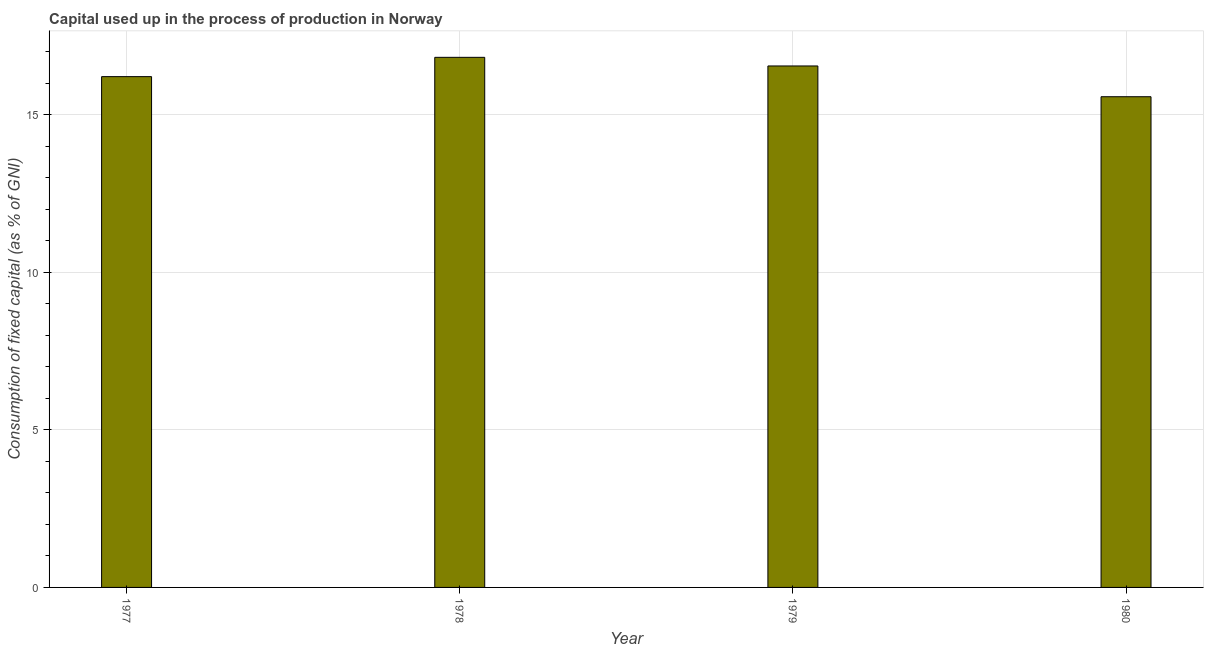What is the title of the graph?
Make the answer very short. Capital used up in the process of production in Norway. What is the label or title of the Y-axis?
Keep it short and to the point. Consumption of fixed capital (as % of GNI). What is the consumption of fixed capital in 1980?
Offer a very short reply. 15.57. Across all years, what is the maximum consumption of fixed capital?
Offer a very short reply. 16.82. Across all years, what is the minimum consumption of fixed capital?
Provide a succinct answer. 15.57. In which year was the consumption of fixed capital maximum?
Ensure brevity in your answer.  1978. What is the sum of the consumption of fixed capital?
Make the answer very short. 65.16. What is the difference between the consumption of fixed capital in 1977 and 1978?
Ensure brevity in your answer.  -0.61. What is the average consumption of fixed capital per year?
Give a very brief answer. 16.29. What is the median consumption of fixed capital?
Make the answer very short. 16.38. In how many years, is the consumption of fixed capital greater than 16 %?
Keep it short and to the point. 3. Do a majority of the years between 1977 and 1979 (inclusive) have consumption of fixed capital greater than 13 %?
Offer a terse response. Yes. What is the ratio of the consumption of fixed capital in 1977 to that in 1980?
Make the answer very short. 1.04. Is the consumption of fixed capital in 1978 less than that in 1980?
Offer a very short reply. No. Is the difference between the consumption of fixed capital in 1977 and 1980 greater than the difference between any two years?
Provide a succinct answer. No. What is the difference between the highest and the second highest consumption of fixed capital?
Offer a terse response. 0.27. Is the sum of the consumption of fixed capital in 1978 and 1980 greater than the maximum consumption of fixed capital across all years?
Keep it short and to the point. Yes. What is the difference between the highest and the lowest consumption of fixed capital?
Make the answer very short. 1.25. In how many years, is the consumption of fixed capital greater than the average consumption of fixed capital taken over all years?
Your response must be concise. 2. How many bars are there?
Your response must be concise. 4. Are all the bars in the graph horizontal?
Provide a succinct answer. No. What is the difference between two consecutive major ticks on the Y-axis?
Offer a terse response. 5. Are the values on the major ticks of Y-axis written in scientific E-notation?
Provide a short and direct response. No. What is the Consumption of fixed capital (as % of GNI) in 1977?
Ensure brevity in your answer.  16.21. What is the Consumption of fixed capital (as % of GNI) of 1978?
Provide a short and direct response. 16.82. What is the Consumption of fixed capital (as % of GNI) in 1979?
Provide a short and direct response. 16.55. What is the Consumption of fixed capital (as % of GNI) in 1980?
Offer a terse response. 15.57. What is the difference between the Consumption of fixed capital (as % of GNI) in 1977 and 1978?
Provide a succinct answer. -0.61. What is the difference between the Consumption of fixed capital (as % of GNI) in 1977 and 1979?
Your response must be concise. -0.34. What is the difference between the Consumption of fixed capital (as % of GNI) in 1977 and 1980?
Offer a very short reply. 0.64. What is the difference between the Consumption of fixed capital (as % of GNI) in 1978 and 1979?
Your answer should be compact. 0.27. What is the difference between the Consumption of fixed capital (as % of GNI) in 1978 and 1980?
Make the answer very short. 1.25. What is the difference between the Consumption of fixed capital (as % of GNI) in 1979 and 1980?
Offer a very short reply. 0.98. What is the ratio of the Consumption of fixed capital (as % of GNI) in 1977 to that in 1980?
Your answer should be very brief. 1.04. What is the ratio of the Consumption of fixed capital (as % of GNI) in 1978 to that in 1979?
Your response must be concise. 1.02. What is the ratio of the Consumption of fixed capital (as % of GNI) in 1978 to that in 1980?
Ensure brevity in your answer.  1.08. What is the ratio of the Consumption of fixed capital (as % of GNI) in 1979 to that in 1980?
Your answer should be very brief. 1.06. 